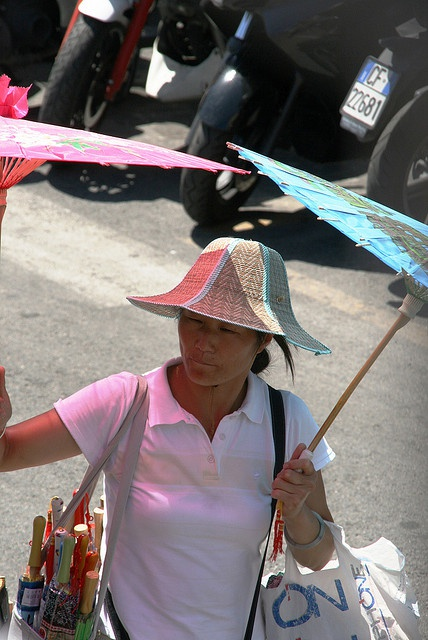Describe the objects in this image and their specific colors. I can see people in black, gray, and maroon tones, motorcycle in black, gray, and purple tones, handbag in black, darkgray, white, and gray tones, motorcycle in black, gray, white, and maroon tones, and umbrella in black, lightblue, gray, and darkgray tones in this image. 